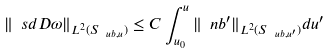Convert formula to latex. <formula><loc_0><loc_0><loc_500><loc_500>\| \ s d D \omega \| _ { L ^ { 2 } ( S _ { \ u b , u } ) } \leq C \int _ { u _ { 0 } } ^ { u } \| \ n b ^ { \prime } \| _ { L ^ { 2 } ( S _ { \ u b , u ^ { \prime } } ) } d u ^ { \prime }</formula> 